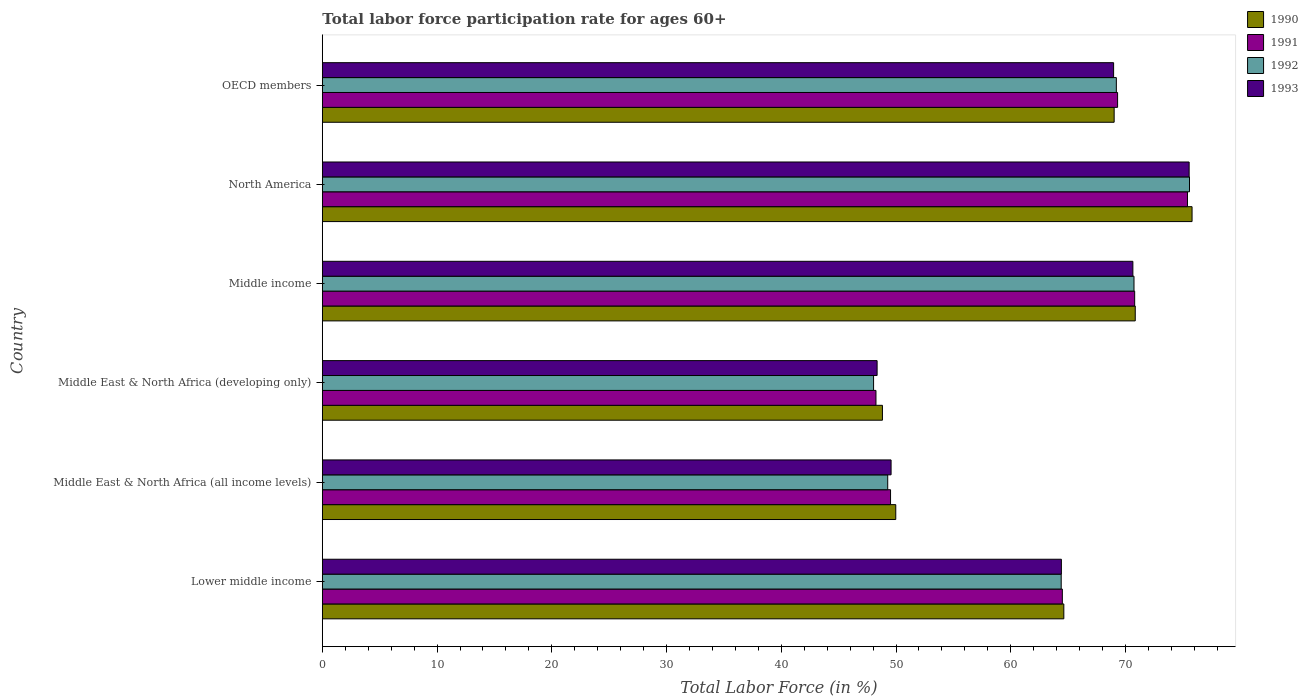How many groups of bars are there?
Ensure brevity in your answer.  6. Are the number of bars per tick equal to the number of legend labels?
Offer a very short reply. Yes. Are the number of bars on each tick of the Y-axis equal?
Your answer should be compact. Yes. How many bars are there on the 5th tick from the top?
Provide a short and direct response. 4. How many bars are there on the 4th tick from the bottom?
Ensure brevity in your answer.  4. What is the label of the 2nd group of bars from the top?
Provide a short and direct response. North America. In how many cases, is the number of bars for a given country not equal to the number of legend labels?
Ensure brevity in your answer.  0. What is the labor force participation rate in 1991 in Lower middle income?
Offer a very short reply. 64.5. Across all countries, what is the maximum labor force participation rate in 1990?
Offer a terse response. 75.8. Across all countries, what is the minimum labor force participation rate in 1992?
Make the answer very short. 48.04. In which country was the labor force participation rate in 1993 maximum?
Your response must be concise. North America. In which country was the labor force participation rate in 1990 minimum?
Keep it short and to the point. Middle East & North Africa (developing only). What is the total labor force participation rate in 1992 in the graph?
Keep it short and to the point. 377.24. What is the difference between the labor force participation rate in 1991 in Middle East & North Africa (developing only) and that in North America?
Make the answer very short. -27.15. What is the difference between the labor force participation rate in 1991 in OECD members and the labor force participation rate in 1990 in Middle East & North Africa (all income levels)?
Give a very brief answer. 19.33. What is the average labor force participation rate in 1993 per country?
Make the answer very short. 62.92. What is the difference between the labor force participation rate in 1991 and labor force participation rate in 1993 in OECD members?
Provide a short and direct response. 0.35. What is the ratio of the labor force participation rate in 1992 in Middle East & North Africa (developing only) to that in North America?
Make the answer very short. 0.64. Is the labor force participation rate in 1993 in Lower middle income less than that in North America?
Your answer should be very brief. Yes. Is the difference between the labor force participation rate in 1991 in Middle East & North Africa (developing only) and Middle income greater than the difference between the labor force participation rate in 1993 in Middle East & North Africa (developing only) and Middle income?
Make the answer very short. No. What is the difference between the highest and the second highest labor force participation rate in 1993?
Keep it short and to the point. 4.9. What is the difference between the highest and the lowest labor force participation rate in 1991?
Your response must be concise. 27.15. Is it the case that in every country, the sum of the labor force participation rate in 1992 and labor force participation rate in 1990 is greater than the sum of labor force participation rate in 1991 and labor force participation rate in 1993?
Your answer should be very brief. No. What does the 1st bar from the bottom in OECD members represents?
Make the answer very short. 1990. Is it the case that in every country, the sum of the labor force participation rate in 1991 and labor force participation rate in 1992 is greater than the labor force participation rate in 1993?
Provide a short and direct response. Yes. How many bars are there?
Your answer should be very brief. 24. Are all the bars in the graph horizontal?
Keep it short and to the point. Yes. How many countries are there in the graph?
Ensure brevity in your answer.  6. What is the difference between two consecutive major ticks on the X-axis?
Offer a terse response. 10. Are the values on the major ticks of X-axis written in scientific E-notation?
Give a very brief answer. No. Does the graph contain any zero values?
Your answer should be compact. No. Does the graph contain grids?
Your response must be concise. No. What is the title of the graph?
Offer a very short reply. Total labor force participation rate for ages 60+. What is the label or title of the Y-axis?
Provide a succinct answer. Country. What is the Total Labor Force (in %) in 1990 in Lower middle income?
Your answer should be compact. 64.63. What is the Total Labor Force (in %) of 1991 in Lower middle income?
Make the answer very short. 64.5. What is the Total Labor Force (in %) of 1992 in Lower middle income?
Keep it short and to the point. 64.4. What is the Total Labor Force (in %) of 1993 in Lower middle income?
Ensure brevity in your answer.  64.41. What is the Total Labor Force (in %) of 1990 in Middle East & North Africa (all income levels)?
Offer a very short reply. 49.98. What is the Total Labor Force (in %) in 1991 in Middle East & North Africa (all income levels)?
Make the answer very short. 49.52. What is the Total Labor Force (in %) of 1992 in Middle East & North Africa (all income levels)?
Give a very brief answer. 49.28. What is the Total Labor Force (in %) of 1993 in Middle East & North Africa (all income levels)?
Keep it short and to the point. 49.57. What is the Total Labor Force (in %) of 1990 in Middle East & North Africa (developing only)?
Ensure brevity in your answer.  48.82. What is the Total Labor Force (in %) of 1991 in Middle East & North Africa (developing only)?
Your answer should be compact. 48.25. What is the Total Labor Force (in %) of 1992 in Middle East & North Africa (developing only)?
Provide a succinct answer. 48.04. What is the Total Labor Force (in %) in 1993 in Middle East & North Africa (developing only)?
Give a very brief answer. 48.35. What is the Total Labor Force (in %) of 1990 in Middle income?
Ensure brevity in your answer.  70.85. What is the Total Labor Force (in %) in 1991 in Middle income?
Offer a very short reply. 70.8. What is the Total Labor Force (in %) in 1992 in Middle income?
Your answer should be very brief. 70.74. What is the Total Labor Force (in %) of 1993 in Middle income?
Offer a terse response. 70.64. What is the Total Labor Force (in %) of 1990 in North America?
Keep it short and to the point. 75.8. What is the Total Labor Force (in %) of 1991 in North America?
Your response must be concise. 75.4. What is the Total Labor Force (in %) in 1992 in North America?
Your answer should be very brief. 75.58. What is the Total Labor Force (in %) of 1993 in North America?
Your answer should be compact. 75.55. What is the Total Labor Force (in %) in 1990 in OECD members?
Give a very brief answer. 69.01. What is the Total Labor Force (in %) of 1991 in OECD members?
Your answer should be compact. 69.31. What is the Total Labor Force (in %) in 1992 in OECD members?
Give a very brief answer. 69.2. What is the Total Labor Force (in %) of 1993 in OECD members?
Ensure brevity in your answer.  68.97. Across all countries, what is the maximum Total Labor Force (in %) of 1990?
Provide a succinct answer. 75.8. Across all countries, what is the maximum Total Labor Force (in %) of 1991?
Make the answer very short. 75.4. Across all countries, what is the maximum Total Labor Force (in %) of 1992?
Your answer should be very brief. 75.58. Across all countries, what is the maximum Total Labor Force (in %) in 1993?
Provide a succinct answer. 75.55. Across all countries, what is the minimum Total Labor Force (in %) in 1990?
Your answer should be very brief. 48.82. Across all countries, what is the minimum Total Labor Force (in %) in 1991?
Make the answer very short. 48.25. Across all countries, what is the minimum Total Labor Force (in %) in 1992?
Provide a short and direct response. 48.04. Across all countries, what is the minimum Total Labor Force (in %) in 1993?
Your answer should be very brief. 48.35. What is the total Total Labor Force (in %) in 1990 in the graph?
Offer a terse response. 379.09. What is the total Total Labor Force (in %) of 1991 in the graph?
Your answer should be very brief. 377.79. What is the total Total Labor Force (in %) in 1992 in the graph?
Give a very brief answer. 377.24. What is the total Total Labor Force (in %) of 1993 in the graph?
Give a very brief answer. 377.49. What is the difference between the Total Labor Force (in %) in 1990 in Lower middle income and that in Middle East & North Africa (all income levels)?
Ensure brevity in your answer.  14.65. What is the difference between the Total Labor Force (in %) in 1991 in Lower middle income and that in Middle East & North Africa (all income levels)?
Make the answer very short. 14.97. What is the difference between the Total Labor Force (in %) of 1992 in Lower middle income and that in Middle East & North Africa (all income levels)?
Give a very brief answer. 15.12. What is the difference between the Total Labor Force (in %) of 1993 in Lower middle income and that in Middle East & North Africa (all income levels)?
Provide a short and direct response. 14.84. What is the difference between the Total Labor Force (in %) in 1990 in Lower middle income and that in Middle East & North Africa (developing only)?
Make the answer very short. 15.81. What is the difference between the Total Labor Force (in %) in 1991 in Lower middle income and that in Middle East & North Africa (developing only)?
Offer a terse response. 16.24. What is the difference between the Total Labor Force (in %) in 1992 in Lower middle income and that in Middle East & North Africa (developing only)?
Offer a very short reply. 16.35. What is the difference between the Total Labor Force (in %) in 1993 in Lower middle income and that in Middle East & North Africa (developing only)?
Offer a terse response. 16.06. What is the difference between the Total Labor Force (in %) of 1990 in Lower middle income and that in Middle income?
Your answer should be compact. -6.22. What is the difference between the Total Labor Force (in %) of 1991 in Lower middle income and that in Middle income?
Keep it short and to the point. -6.3. What is the difference between the Total Labor Force (in %) of 1992 in Lower middle income and that in Middle income?
Make the answer very short. -6.34. What is the difference between the Total Labor Force (in %) in 1993 in Lower middle income and that in Middle income?
Offer a terse response. -6.23. What is the difference between the Total Labor Force (in %) of 1990 in Lower middle income and that in North America?
Your answer should be compact. -11.18. What is the difference between the Total Labor Force (in %) of 1991 in Lower middle income and that in North America?
Provide a succinct answer. -10.91. What is the difference between the Total Labor Force (in %) of 1992 in Lower middle income and that in North America?
Your answer should be very brief. -11.18. What is the difference between the Total Labor Force (in %) of 1993 in Lower middle income and that in North America?
Provide a succinct answer. -11.14. What is the difference between the Total Labor Force (in %) of 1990 in Lower middle income and that in OECD members?
Your answer should be very brief. -4.39. What is the difference between the Total Labor Force (in %) in 1991 in Lower middle income and that in OECD members?
Your answer should be very brief. -4.81. What is the difference between the Total Labor Force (in %) in 1992 in Lower middle income and that in OECD members?
Your response must be concise. -4.81. What is the difference between the Total Labor Force (in %) in 1993 in Lower middle income and that in OECD members?
Ensure brevity in your answer.  -4.55. What is the difference between the Total Labor Force (in %) in 1990 in Middle East & North Africa (all income levels) and that in Middle East & North Africa (developing only)?
Provide a short and direct response. 1.16. What is the difference between the Total Labor Force (in %) of 1991 in Middle East & North Africa (all income levels) and that in Middle East & North Africa (developing only)?
Give a very brief answer. 1.27. What is the difference between the Total Labor Force (in %) of 1992 in Middle East & North Africa (all income levels) and that in Middle East & North Africa (developing only)?
Your answer should be very brief. 1.23. What is the difference between the Total Labor Force (in %) of 1993 in Middle East & North Africa (all income levels) and that in Middle East & North Africa (developing only)?
Provide a short and direct response. 1.22. What is the difference between the Total Labor Force (in %) of 1990 in Middle East & North Africa (all income levels) and that in Middle income?
Ensure brevity in your answer.  -20.87. What is the difference between the Total Labor Force (in %) in 1991 in Middle East & North Africa (all income levels) and that in Middle income?
Offer a terse response. -21.28. What is the difference between the Total Labor Force (in %) of 1992 in Middle East & North Africa (all income levels) and that in Middle income?
Your response must be concise. -21.46. What is the difference between the Total Labor Force (in %) in 1993 in Middle East & North Africa (all income levels) and that in Middle income?
Give a very brief answer. -21.07. What is the difference between the Total Labor Force (in %) of 1990 in Middle East & North Africa (all income levels) and that in North America?
Keep it short and to the point. -25.82. What is the difference between the Total Labor Force (in %) in 1991 in Middle East & North Africa (all income levels) and that in North America?
Keep it short and to the point. -25.88. What is the difference between the Total Labor Force (in %) of 1992 in Middle East & North Africa (all income levels) and that in North America?
Ensure brevity in your answer.  -26.3. What is the difference between the Total Labor Force (in %) of 1993 in Middle East & North Africa (all income levels) and that in North America?
Provide a succinct answer. -25.98. What is the difference between the Total Labor Force (in %) in 1990 in Middle East & North Africa (all income levels) and that in OECD members?
Provide a succinct answer. -19.03. What is the difference between the Total Labor Force (in %) of 1991 in Middle East & North Africa (all income levels) and that in OECD members?
Your answer should be compact. -19.79. What is the difference between the Total Labor Force (in %) of 1992 in Middle East & North Africa (all income levels) and that in OECD members?
Give a very brief answer. -19.93. What is the difference between the Total Labor Force (in %) of 1993 in Middle East & North Africa (all income levels) and that in OECD members?
Provide a short and direct response. -19.39. What is the difference between the Total Labor Force (in %) in 1990 in Middle East & North Africa (developing only) and that in Middle income?
Your answer should be compact. -22.03. What is the difference between the Total Labor Force (in %) of 1991 in Middle East & North Africa (developing only) and that in Middle income?
Ensure brevity in your answer.  -22.55. What is the difference between the Total Labor Force (in %) of 1992 in Middle East & North Africa (developing only) and that in Middle income?
Provide a short and direct response. -22.7. What is the difference between the Total Labor Force (in %) of 1993 in Middle East & North Africa (developing only) and that in Middle income?
Provide a succinct answer. -22.29. What is the difference between the Total Labor Force (in %) of 1990 in Middle East & North Africa (developing only) and that in North America?
Offer a terse response. -26.99. What is the difference between the Total Labor Force (in %) of 1991 in Middle East & North Africa (developing only) and that in North America?
Your answer should be compact. -27.15. What is the difference between the Total Labor Force (in %) of 1992 in Middle East & North Africa (developing only) and that in North America?
Offer a terse response. -27.53. What is the difference between the Total Labor Force (in %) of 1993 in Middle East & North Africa (developing only) and that in North America?
Your answer should be very brief. -27.2. What is the difference between the Total Labor Force (in %) in 1990 in Middle East & North Africa (developing only) and that in OECD members?
Provide a succinct answer. -20.2. What is the difference between the Total Labor Force (in %) of 1991 in Middle East & North Africa (developing only) and that in OECD members?
Keep it short and to the point. -21.06. What is the difference between the Total Labor Force (in %) of 1992 in Middle East & North Africa (developing only) and that in OECD members?
Your answer should be compact. -21.16. What is the difference between the Total Labor Force (in %) of 1993 in Middle East & North Africa (developing only) and that in OECD members?
Ensure brevity in your answer.  -20.61. What is the difference between the Total Labor Force (in %) of 1990 in Middle income and that in North America?
Keep it short and to the point. -4.95. What is the difference between the Total Labor Force (in %) of 1991 in Middle income and that in North America?
Offer a terse response. -4.6. What is the difference between the Total Labor Force (in %) in 1992 in Middle income and that in North America?
Offer a very short reply. -4.84. What is the difference between the Total Labor Force (in %) of 1993 in Middle income and that in North America?
Make the answer very short. -4.9. What is the difference between the Total Labor Force (in %) of 1990 in Middle income and that in OECD members?
Make the answer very short. 1.84. What is the difference between the Total Labor Force (in %) in 1991 in Middle income and that in OECD members?
Ensure brevity in your answer.  1.49. What is the difference between the Total Labor Force (in %) in 1992 in Middle income and that in OECD members?
Make the answer very short. 1.54. What is the difference between the Total Labor Force (in %) in 1993 in Middle income and that in OECD members?
Provide a short and direct response. 1.68. What is the difference between the Total Labor Force (in %) of 1990 in North America and that in OECD members?
Make the answer very short. 6.79. What is the difference between the Total Labor Force (in %) in 1991 in North America and that in OECD members?
Make the answer very short. 6.09. What is the difference between the Total Labor Force (in %) of 1992 in North America and that in OECD members?
Ensure brevity in your answer.  6.38. What is the difference between the Total Labor Force (in %) of 1993 in North America and that in OECD members?
Your answer should be very brief. 6.58. What is the difference between the Total Labor Force (in %) in 1990 in Lower middle income and the Total Labor Force (in %) in 1991 in Middle East & North Africa (all income levels)?
Provide a short and direct response. 15.1. What is the difference between the Total Labor Force (in %) of 1990 in Lower middle income and the Total Labor Force (in %) of 1992 in Middle East & North Africa (all income levels)?
Provide a short and direct response. 15.35. What is the difference between the Total Labor Force (in %) of 1990 in Lower middle income and the Total Labor Force (in %) of 1993 in Middle East & North Africa (all income levels)?
Offer a very short reply. 15.06. What is the difference between the Total Labor Force (in %) of 1991 in Lower middle income and the Total Labor Force (in %) of 1992 in Middle East & North Africa (all income levels)?
Provide a succinct answer. 15.22. What is the difference between the Total Labor Force (in %) of 1991 in Lower middle income and the Total Labor Force (in %) of 1993 in Middle East & North Africa (all income levels)?
Your answer should be very brief. 14.93. What is the difference between the Total Labor Force (in %) of 1992 in Lower middle income and the Total Labor Force (in %) of 1993 in Middle East & North Africa (all income levels)?
Offer a very short reply. 14.83. What is the difference between the Total Labor Force (in %) of 1990 in Lower middle income and the Total Labor Force (in %) of 1991 in Middle East & North Africa (developing only)?
Provide a succinct answer. 16.37. What is the difference between the Total Labor Force (in %) of 1990 in Lower middle income and the Total Labor Force (in %) of 1992 in Middle East & North Africa (developing only)?
Offer a terse response. 16.58. What is the difference between the Total Labor Force (in %) in 1990 in Lower middle income and the Total Labor Force (in %) in 1993 in Middle East & North Africa (developing only)?
Give a very brief answer. 16.27. What is the difference between the Total Labor Force (in %) in 1991 in Lower middle income and the Total Labor Force (in %) in 1992 in Middle East & North Africa (developing only)?
Your response must be concise. 16.45. What is the difference between the Total Labor Force (in %) in 1991 in Lower middle income and the Total Labor Force (in %) in 1993 in Middle East & North Africa (developing only)?
Your answer should be very brief. 16.15. What is the difference between the Total Labor Force (in %) of 1992 in Lower middle income and the Total Labor Force (in %) of 1993 in Middle East & North Africa (developing only)?
Offer a terse response. 16.05. What is the difference between the Total Labor Force (in %) in 1990 in Lower middle income and the Total Labor Force (in %) in 1991 in Middle income?
Offer a very short reply. -6.17. What is the difference between the Total Labor Force (in %) in 1990 in Lower middle income and the Total Labor Force (in %) in 1992 in Middle income?
Offer a terse response. -6.12. What is the difference between the Total Labor Force (in %) of 1990 in Lower middle income and the Total Labor Force (in %) of 1993 in Middle income?
Your answer should be compact. -6.02. What is the difference between the Total Labor Force (in %) of 1991 in Lower middle income and the Total Labor Force (in %) of 1992 in Middle income?
Your answer should be compact. -6.24. What is the difference between the Total Labor Force (in %) in 1991 in Lower middle income and the Total Labor Force (in %) in 1993 in Middle income?
Make the answer very short. -6.15. What is the difference between the Total Labor Force (in %) in 1992 in Lower middle income and the Total Labor Force (in %) in 1993 in Middle income?
Provide a short and direct response. -6.25. What is the difference between the Total Labor Force (in %) of 1990 in Lower middle income and the Total Labor Force (in %) of 1991 in North America?
Your answer should be very brief. -10.78. What is the difference between the Total Labor Force (in %) in 1990 in Lower middle income and the Total Labor Force (in %) in 1992 in North America?
Ensure brevity in your answer.  -10.95. What is the difference between the Total Labor Force (in %) of 1990 in Lower middle income and the Total Labor Force (in %) of 1993 in North America?
Your answer should be compact. -10.92. What is the difference between the Total Labor Force (in %) in 1991 in Lower middle income and the Total Labor Force (in %) in 1992 in North America?
Your answer should be very brief. -11.08. What is the difference between the Total Labor Force (in %) of 1991 in Lower middle income and the Total Labor Force (in %) of 1993 in North America?
Ensure brevity in your answer.  -11.05. What is the difference between the Total Labor Force (in %) in 1992 in Lower middle income and the Total Labor Force (in %) in 1993 in North America?
Ensure brevity in your answer.  -11.15. What is the difference between the Total Labor Force (in %) in 1990 in Lower middle income and the Total Labor Force (in %) in 1991 in OECD members?
Make the answer very short. -4.69. What is the difference between the Total Labor Force (in %) of 1990 in Lower middle income and the Total Labor Force (in %) of 1992 in OECD members?
Make the answer very short. -4.58. What is the difference between the Total Labor Force (in %) of 1990 in Lower middle income and the Total Labor Force (in %) of 1993 in OECD members?
Provide a succinct answer. -4.34. What is the difference between the Total Labor Force (in %) in 1991 in Lower middle income and the Total Labor Force (in %) in 1992 in OECD members?
Your answer should be very brief. -4.71. What is the difference between the Total Labor Force (in %) of 1991 in Lower middle income and the Total Labor Force (in %) of 1993 in OECD members?
Offer a terse response. -4.47. What is the difference between the Total Labor Force (in %) in 1992 in Lower middle income and the Total Labor Force (in %) in 1993 in OECD members?
Your answer should be compact. -4.57. What is the difference between the Total Labor Force (in %) of 1990 in Middle East & North Africa (all income levels) and the Total Labor Force (in %) of 1991 in Middle East & North Africa (developing only)?
Provide a succinct answer. 1.73. What is the difference between the Total Labor Force (in %) in 1990 in Middle East & North Africa (all income levels) and the Total Labor Force (in %) in 1992 in Middle East & North Africa (developing only)?
Give a very brief answer. 1.93. What is the difference between the Total Labor Force (in %) in 1990 in Middle East & North Africa (all income levels) and the Total Labor Force (in %) in 1993 in Middle East & North Africa (developing only)?
Keep it short and to the point. 1.63. What is the difference between the Total Labor Force (in %) of 1991 in Middle East & North Africa (all income levels) and the Total Labor Force (in %) of 1992 in Middle East & North Africa (developing only)?
Offer a terse response. 1.48. What is the difference between the Total Labor Force (in %) of 1991 in Middle East & North Africa (all income levels) and the Total Labor Force (in %) of 1993 in Middle East & North Africa (developing only)?
Your answer should be very brief. 1.17. What is the difference between the Total Labor Force (in %) in 1992 in Middle East & North Africa (all income levels) and the Total Labor Force (in %) in 1993 in Middle East & North Africa (developing only)?
Provide a short and direct response. 0.93. What is the difference between the Total Labor Force (in %) of 1990 in Middle East & North Africa (all income levels) and the Total Labor Force (in %) of 1991 in Middle income?
Your answer should be compact. -20.82. What is the difference between the Total Labor Force (in %) in 1990 in Middle East & North Africa (all income levels) and the Total Labor Force (in %) in 1992 in Middle income?
Offer a very short reply. -20.76. What is the difference between the Total Labor Force (in %) in 1990 in Middle East & North Africa (all income levels) and the Total Labor Force (in %) in 1993 in Middle income?
Offer a terse response. -20.66. What is the difference between the Total Labor Force (in %) of 1991 in Middle East & North Africa (all income levels) and the Total Labor Force (in %) of 1992 in Middle income?
Your answer should be compact. -21.22. What is the difference between the Total Labor Force (in %) of 1991 in Middle East & North Africa (all income levels) and the Total Labor Force (in %) of 1993 in Middle income?
Make the answer very short. -21.12. What is the difference between the Total Labor Force (in %) of 1992 in Middle East & North Africa (all income levels) and the Total Labor Force (in %) of 1993 in Middle income?
Your answer should be compact. -21.37. What is the difference between the Total Labor Force (in %) in 1990 in Middle East & North Africa (all income levels) and the Total Labor Force (in %) in 1991 in North America?
Ensure brevity in your answer.  -25.42. What is the difference between the Total Labor Force (in %) in 1990 in Middle East & North Africa (all income levels) and the Total Labor Force (in %) in 1992 in North America?
Keep it short and to the point. -25.6. What is the difference between the Total Labor Force (in %) of 1990 in Middle East & North Africa (all income levels) and the Total Labor Force (in %) of 1993 in North America?
Provide a succinct answer. -25.57. What is the difference between the Total Labor Force (in %) of 1991 in Middle East & North Africa (all income levels) and the Total Labor Force (in %) of 1992 in North America?
Offer a very short reply. -26.06. What is the difference between the Total Labor Force (in %) in 1991 in Middle East & North Africa (all income levels) and the Total Labor Force (in %) in 1993 in North America?
Your answer should be compact. -26.03. What is the difference between the Total Labor Force (in %) of 1992 in Middle East & North Africa (all income levels) and the Total Labor Force (in %) of 1993 in North America?
Keep it short and to the point. -26.27. What is the difference between the Total Labor Force (in %) of 1990 in Middle East & North Africa (all income levels) and the Total Labor Force (in %) of 1991 in OECD members?
Provide a succinct answer. -19.33. What is the difference between the Total Labor Force (in %) of 1990 in Middle East & North Africa (all income levels) and the Total Labor Force (in %) of 1992 in OECD members?
Provide a short and direct response. -19.22. What is the difference between the Total Labor Force (in %) in 1990 in Middle East & North Africa (all income levels) and the Total Labor Force (in %) in 1993 in OECD members?
Give a very brief answer. -18.99. What is the difference between the Total Labor Force (in %) of 1991 in Middle East & North Africa (all income levels) and the Total Labor Force (in %) of 1992 in OECD members?
Your answer should be compact. -19.68. What is the difference between the Total Labor Force (in %) in 1991 in Middle East & North Africa (all income levels) and the Total Labor Force (in %) in 1993 in OECD members?
Provide a succinct answer. -19.44. What is the difference between the Total Labor Force (in %) of 1992 in Middle East & North Africa (all income levels) and the Total Labor Force (in %) of 1993 in OECD members?
Offer a terse response. -19.69. What is the difference between the Total Labor Force (in %) in 1990 in Middle East & North Africa (developing only) and the Total Labor Force (in %) in 1991 in Middle income?
Offer a very short reply. -21.98. What is the difference between the Total Labor Force (in %) in 1990 in Middle East & North Africa (developing only) and the Total Labor Force (in %) in 1992 in Middle income?
Offer a terse response. -21.93. What is the difference between the Total Labor Force (in %) of 1990 in Middle East & North Africa (developing only) and the Total Labor Force (in %) of 1993 in Middle income?
Give a very brief answer. -21.83. What is the difference between the Total Labor Force (in %) in 1991 in Middle East & North Africa (developing only) and the Total Labor Force (in %) in 1992 in Middle income?
Provide a short and direct response. -22.49. What is the difference between the Total Labor Force (in %) in 1991 in Middle East & North Africa (developing only) and the Total Labor Force (in %) in 1993 in Middle income?
Keep it short and to the point. -22.39. What is the difference between the Total Labor Force (in %) in 1992 in Middle East & North Africa (developing only) and the Total Labor Force (in %) in 1993 in Middle income?
Your response must be concise. -22.6. What is the difference between the Total Labor Force (in %) of 1990 in Middle East & North Africa (developing only) and the Total Labor Force (in %) of 1991 in North America?
Your answer should be very brief. -26.59. What is the difference between the Total Labor Force (in %) in 1990 in Middle East & North Africa (developing only) and the Total Labor Force (in %) in 1992 in North America?
Give a very brief answer. -26.76. What is the difference between the Total Labor Force (in %) of 1990 in Middle East & North Africa (developing only) and the Total Labor Force (in %) of 1993 in North America?
Your response must be concise. -26.73. What is the difference between the Total Labor Force (in %) of 1991 in Middle East & North Africa (developing only) and the Total Labor Force (in %) of 1992 in North America?
Offer a terse response. -27.33. What is the difference between the Total Labor Force (in %) of 1991 in Middle East & North Africa (developing only) and the Total Labor Force (in %) of 1993 in North America?
Your answer should be very brief. -27.3. What is the difference between the Total Labor Force (in %) of 1992 in Middle East & North Africa (developing only) and the Total Labor Force (in %) of 1993 in North America?
Provide a short and direct response. -27.5. What is the difference between the Total Labor Force (in %) in 1990 in Middle East & North Africa (developing only) and the Total Labor Force (in %) in 1991 in OECD members?
Offer a very short reply. -20.5. What is the difference between the Total Labor Force (in %) in 1990 in Middle East & North Africa (developing only) and the Total Labor Force (in %) in 1992 in OECD members?
Make the answer very short. -20.39. What is the difference between the Total Labor Force (in %) in 1990 in Middle East & North Africa (developing only) and the Total Labor Force (in %) in 1993 in OECD members?
Make the answer very short. -20.15. What is the difference between the Total Labor Force (in %) of 1991 in Middle East & North Africa (developing only) and the Total Labor Force (in %) of 1992 in OECD members?
Your answer should be very brief. -20.95. What is the difference between the Total Labor Force (in %) of 1991 in Middle East & North Africa (developing only) and the Total Labor Force (in %) of 1993 in OECD members?
Keep it short and to the point. -20.71. What is the difference between the Total Labor Force (in %) in 1992 in Middle East & North Africa (developing only) and the Total Labor Force (in %) in 1993 in OECD members?
Your response must be concise. -20.92. What is the difference between the Total Labor Force (in %) of 1990 in Middle income and the Total Labor Force (in %) of 1991 in North America?
Offer a very short reply. -4.55. What is the difference between the Total Labor Force (in %) in 1990 in Middle income and the Total Labor Force (in %) in 1992 in North America?
Keep it short and to the point. -4.73. What is the difference between the Total Labor Force (in %) of 1990 in Middle income and the Total Labor Force (in %) of 1993 in North America?
Your response must be concise. -4.7. What is the difference between the Total Labor Force (in %) of 1991 in Middle income and the Total Labor Force (in %) of 1992 in North America?
Offer a terse response. -4.78. What is the difference between the Total Labor Force (in %) of 1991 in Middle income and the Total Labor Force (in %) of 1993 in North America?
Your response must be concise. -4.75. What is the difference between the Total Labor Force (in %) in 1992 in Middle income and the Total Labor Force (in %) in 1993 in North America?
Keep it short and to the point. -4.81. What is the difference between the Total Labor Force (in %) in 1990 in Middle income and the Total Labor Force (in %) in 1991 in OECD members?
Provide a short and direct response. 1.54. What is the difference between the Total Labor Force (in %) of 1990 in Middle income and the Total Labor Force (in %) of 1992 in OECD members?
Provide a short and direct response. 1.65. What is the difference between the Total Labor Force (in %) of 1990 in Middle income and the Total Labor Force (in %) of 1993 in OECD members?
Give a very brief answer. 1.89. What is the difference between the Total Labor Force (in %) of 1991 in Middle income and the Total Labor Force (in %) of 1992 in OECD members?
Offer a very short reply. 1.6. What is the difference between the Total Labor Force (in %) in 1991 in Middle income and the Total Labor Force (in %) in 1993 in OECD members?
Give a very brief answer. 1.84. What is the difference between the Total Labor Force (in %) in 1992 in Middle income and the Total Labor Force (in %) in 1993 in OECD members?
Make the answer very short. 1.78. What is the difference between the Total Labor Force (in %) in 1990 in North America and the Total Labor Force (in %) in 1991 in OECD members?
Keep it short and to the point. 6.49. What is the difference between the Total Labor Force (in %) of 1990 in North America and the Total Labor Force (in %) of 1992 in OECD members?
Make the answer very short. 6.6. What is the difference between the Total Labor Force (in %) of 1990 in North America and the Total Labor Force (in %) of 1993 in OECD members?
Keep it short and to the point. 6.84. What is the difference between the Total Labor Force (in %) in 1991 in North America and the Total Labor Force (in %) in 1992 in OECD members?
Offer a terse response. 6.2. What is the difference between the Total Labor Force (in %) in 1991 in North America and the Total Labor Force (in %) in 1993 in OECD members?
Provide a succinct answer. 6.44. What is the difference between the Total Labor Force (in %) in 1992 in North America and the Total Labor Force (in %) in 1993 in OECD members?
Your answer should be compact. 6.61. What is the average Total Labor Force (in %) of 1990 per country?
Ensure brevity in your answer.  63.18. What is the average Total Labor Force (in %) of 1991 per country?
Keep it short and to the point. 62.96. What is the average Total Labor Force (in %) of 1992 per country?
Your answer should be compact. 62.87. What is the average Total Labor Force (in %) of 1993 per country?
Provide a short and direct response. 62.92. What is the difference between the Total Labor Force (in %) of 1990 and Total Labor Force (in %) of 1991 in Lower middle income?
Your answer should be very brief. 0.13. What is the difference between the Total Labor Force (in %) of 1990 and Total Labor Force (in %) of 1992 in Lower middle income?
Offer a very short reply. 0.23. What is the difference between the Total Labor Force (in %) of 1990 and Total Labor Force (in %) of 1993 in Lower middle income?
Offer a very short reply. 0.21. What is the difference between the Total Labor Force (in %) of 1991 and Total Labor Force (in %) of 1992 in Lower middle income?
Offer a terse response. 0.1. What is the difference between the Total Labor Force (in %) in 1991 and Total Labor Force (in %) in 1993 in Lower middle income?
Your answer should be compact. 0.08. What is the difference between the Total Labor Force (in %) in 1992 and Total Labor Force (in %) in 1993 in Lower middle income?
Give a very brief answer. -0.02. What is the difference between the Total Labor Force (in %) in 1990 and Total Labor Force (in %) in 1991 in Middle East & North Africa (all income levels)?
Ensure brevity in your answer.  0.46. What is the difference between the Total Labor Force (in %) of 1990 and Total Labor Force (in %) of 1992 in Middle East & North Africa (all income levels)?
Give a very brief answer. 0.7. What is the difference between the Total Labor Force (in %) of 1990 and Total Labor Force (in %) of 1993 in Middle East & North Africa (all income levels)?
Your answer should be very brief. 0.41. What is the difference between the Total Labor Force (in %) of 1991 and Total Labor Force (in %) of 1992 in Middle East & North Africa (all income levels)?
Your response must be concise. 0.25. What is the difference between the Total Labor Force (in %) in 1991 and Total Labor Force (in %) in 1993 in Middle East & North Africa (all income levels)?
Make the answer very short. -0.05. What is the difference between the Total Labor Force (in %) of 1992 and Total Labor Force (in %) of 1993 in Middle East & North Africa (all income levels)?
Your answer should be compact. -0.29. What is the difference between the Total Labor Force (in %) in 1990 and Total Labor Force (in %) in 1991 in Middle East & North Africa (developing only)?
Provide a short and direct response. 0.56. What is the difference between the Total Labor Force (in %) in 1990 and Total Labor Force (in %) in 1992 in Middle East & North Africa (developing only)?
Make the answer very short. 0.77. What is the difference between the Total Labor Force (in %) of 1990 and Total Labor Force (in %) of 1993 in Middle East & North Africa (developing only)?
Provide a short and direct response. 0.46. What is the difference between the Total Labor Force (in %) in 1991 and Total Labor Force (in %) in 1992 in Middle East & North Africa (developing only)?
Offer a very short reply. 0.21. What is the difference between the Total Labor Force (in %) in 1991 and Total Labor Force (in %) in 1993 in Middle East & North Africa (developing only)?
Provide a succinct answer. -0.1. What is the difference between the Total Labor Force (in %) of 1992 and Total Labor Force (in %) of 1993 in Middle East & North Africa (developing only)?
Keep it short and to the point. -0.31. What is the difference between the Total Labor Force (in %) in 1990 and Total Labor Force (in %) in 1991 in Middle income?
Keep it short and to the point. 0.05. What is the difference between the Total Labor Force (in %) in 1990 and Total Labor Force (in %) in 1992 in Middle income?
Your answer should be compact. 0.11. What is the difference between the Total Labor Force (in %) in 1990 and Total Labor Force (in %) in 1993 in Middle income?
Offer a terse response. 0.21. What is the difference between the Total Labor Force (in %) of 1991 and Total Labor Force (in %) of 1992 in Middle income?
Make the answer very short. 0.06. What is the difference between the Total Labor Force (in %) in 1991 and Total Labor Force (in %) in 1993 in Middle income?
Offer a terse response. 0.16. What is the difference between the Total Labor Force (in %) of 1992 and Total Labor Force (in %) of 1993 in Middle income?
Offer a very short reply. 0.1. What is the difference between the Total Labor Force (in %) in 1990 and Total Labor Force (in %) in 1991 in North America?
Your answer should be very brief. 0.4. What is the difference between the Total Labor Force (in %) of 1990 and Total Labor Force (in %) of 1992 in North America?
Offer a terse response. 0.22. What is the difference between the Total Labor Force (in %) in 1990 and Total Labor Force (in %) in 1993 in North America?
Offer a very short reply. 0.25. What is the difference between the Total Labor Force (in %) in 1991 and Total Labor Force (in %) in 1992 in North America?
Give a very brief answer. -0.18. What is the difference between the Total Labor Force (in %) of 1991 and Total Labor Force (in %) of 1993 in North America?
Offer a very short reply. -0.15. What is the difference between the Total Labor Force (in %) of 1992 and Total Labor Force (in %) of 1993 in North America?
Provide a succinct answer. 0.03. What is the difference between the Total Labor Force (in %) of 1990 and Total Labor Force (in %) of 1991 in OECD members?
Make the answer very short. -0.3. What is the difference between the Total Labor Force (in %) of 1990 and Total Labor Force (in %) of 1992 in OECD members?
Give a very brief answer. -0.19. What is the difference between the Total Labor Force (in %) in 1990 and Total Labor Force (in %) in 1993 in OECD members?
Ensure brevity in your answer.  0.05. What is the difference between the Total Labor Force (in %) of 1991 and Total Labor Force (in %) of 1992 in OECD members?
Your answer should be very brief. 0.11. What is the difference between the Total Labor Force (in %) of 1991 and Total Labor Force (in %) of 1993 in OECD members?
Provide a succinct answer. 0.35. What is the difference between the Total Labor Force (in %) of 1992 and Total Labor Force (in %) of 1993 in OECD members?
Provide a succinct answer. 0.24. What is the ratio of the Total Labor Force (in %) in 1990 in Lower middle income to that in Middle East & North Africa (all income levels)?
Give a very brief answer. 1.29. What is the ratio of the Total Labor Force (in %) in 1991 in Lower middle income to that in Middle East & North Africa (all income levels)?
Offer a terse response. 1.3. What is the ratio of the Total Labor Force (in %) of 1992 in Lower middle income to that in Middle East & North Africa (all income levels)?
Provide a succinct answer. 1.31. What is the ratio of the Total Labor Force (in %) in 1993 in Lower middle income to that in Middle East & North Africa (all income levels)?
Keep it short and to the point. 1.3. What is the ratio of the Total Labor Force (in %) in 1990 in Lower middle income to that in Middle East & North Africa (developing only)?
Provide a succinct answer. 1.32. What is the ratio of the Total Labor Force (in %) of 1991 in Lower middle income to that in Middle East & North Africa (developing only)?
Make the answer very short. 1.34. What is the ratio of the Total Labor Force (in %) in 1992 in Lower middle income to that in Middle East & North Africa (developing only)?
Ensure brevity in your answer.  1.34. What is the ratio of the Total Labor Force (in %) of 1993 in Lower middle income to that in Middle East & North Africa (developing only)?
Offer a terse response. 1.33. What is the ratio of the Total Labor Force (in %) of 1990 in Lower middle income to that in Middle income?
Make the answer very short. 0.91. What is the ratio of the Total Labor Force (in %) in 1991 in Lower middle income to that in Middle income?
Give a very brief answer. 0.91. What is the ratio of the Total Labor Force (in %) in 1992 in Lower middle income to that in Middle income?
Ensure brevity in your answer.  0.91. What is the ratio of the Total Labor Force (in %) in 1993 in Lower middle income to that in Middle income?
Provide a short and direct response. 0.91. What is the ratio of the Total Labor Force (in %) of 1990 in Lower middle income to that in North America?
Make the answer very short. 0.85. What is the ratio of the Total Labor Force (in %) in 1991 in Lower middle income to that in North America?
Ensure brevity in your answer.  0.86. What is the ratio of the Total Labor Force (in %) of 1992 in Lower middle income to that in North America?
Your answer should be very brief. 0.85. What is the ratio of the Total Labor Force (in %) in 1993 in Lower middle income to that in North America?
Provide a short and direct response. 0.85. What is the ratio of the Total Labor Force (in %) in 1990 in Lower middle income to that in OECD members?
Make the answer very short. 0.94. What is the ratio of the Total Labor Force (in %) in 1991 in Lower middle income to that in OECD members?
Keep it short and to the point. 0.93. What is the ratio of the Total Labor Force (in %) in 1992 in Lower middle income to that in OECD members?
Keep it short and to the point. 0.93. What is the ratio of the Total Labor Force (in %) in 1993 in Lower middle income to that in OECD members?
Give a very brief answer. 0.93. What is the ratio of the Total Labor Force (in %) in 1990 in Middle East & North Africa (all income levels) to that in Middle East & North Africa (developing only)?
Give a very brief answer. 1.02. What is the ratio of the Total Labor Force (in %) of 1991 in Middle East & North Africa (all income levels) to that in Middle East & North Africa (developing only)?
Ensure brevity in your answer.  1.03. What is the ratio of the Total Labor Force (in %) of 1992 in Middle East & North Africa (all income levels) to that in Middle East & North Africa (developing only)?
Make the answer very short. 1.03. What is the ratio of the Total Labor Force (in %) of 1993 in Middle East & North Africa (all income levels) to that in Middle East & North Africa (developing only)?
Ensure brevity in your answer.  1.03. What is the ratio of the Total Labor Force (in %) of 1990 in Middle East & North Africa (all income levels) to that in Middle income?
Your answer should be compact. 0.71. What is the ratio of the Total Labor Force (in %) of 1991 in Middle East & North Africa (all income levels) to that in Middle income?
Give a very brief answer. 0.7. What is the ratio of the Total Labor Force (in %) in 1992 in Middle East & North Africa (all income levels) to that in Middle income?
Give a very brief answer. 0.7. What is the ratio of the Total Labor Force (in %) in 1993 in Middle East & North Africa (all income levels) to that in Middle income?
Ensure brevity in your answer.  0.7. What is the ratio of the Total Labor Force (in %) in 1990 in Middle East & North Africa (all income levels) to that in North America?
Provide a succinct answer. 0.66. What is the ratio of the Total Labor Force (in %) of 1991 in Middle East & North Africa (all income levels) to that in North America?
Your response must be concise. 0.66. What is the ratio of the Total Labor Force (in %) in 1992 in Middle East & North Africa (all income levels) to that in North America?
Offer a terse response. 0.65. What is the ratio of the Total Labor Force (in %) of 1993 in Middle East & North Africa (all income levels) to that in North America?
Provide a succinct answer. 0.66. What is the ratio of the Total Labor Force (in %) in 1990 in Middle East & North Africa (all income levels) to that in OECD members?
Provide a succinct answer. 0.72. What is the ratio of the Total Labor Force (in %) in 1991 in Middle East & North Africa (all income levels) to that in OECD members?
Ensure brevity in your answer.  0.71. What is the ratio of the Total Labor Force (in %) of 1992 in Middle East & North Africa (all income levels) to that in OECD members?
Ensure brevity in your answer.  0.71. What is the ratio of the Total Labor Force (in %) in 1993 in Middle East & North Africa (all income levels) to that in OECD members?
Provide a short and direct response. 0.72. What is the ratio of the Total Labor Force (in %) of 1990 in Middle East & North Africa (developing only) to that in Middle income?
Ensure brevity in your answer.  0.69. What is the ratio of the Total Labor Force (in %) of 1991 in Middle East & North Africa (developing only) to that in Middle income?
Your response must be concise. 0.68. What is the ratio of the Total Labor Force (in %) in 1992 in Middle East & North Africa (developing only) to that in Middle income?
Your answer should be very brief. 0.68. What is the ratio of the Total Labor Force (in %) of 1993 in Middle East & North Africa (developing only) to that in Middle income?
Ensure brevity in your answer.  0.68. What is the ratio of the Total Labor Force (in %) of 1990 in Middle East & North Africa (developing only) to that in North America?
Provide a succinct answer. 0.64. What is the ratio of the Total Labor Force (in %) of 1991 in Middle East & North Africa (developing only) to that in North America?
Your answer should be compact. 0.64. What is the ratio of the Total Labor Force (in %) of 1992 in Middle East & North Africa (developing only) to that in North America?
Your response must be concise. 0.64. What is the ratio of the Total Labor Force (in %) in 1993 in Middle East & North Africa (developing only) to that in North America?
Make the answer very short. 0.64. What is the ratio of the Total Labor Force (in %) in 1990 in Middle East & North Africa (developing only) to that in OECD members?
Your answer should be compact. 0.71. What is the ratio of the Total Labor Force (in %) in 1991 in Middle East & North Africa (developing only) to that in OECD members?
Your answer should be very brief. 0.7. What is the ratio of the Total Labor Force (in %) in 1992 in Middle East & North Africa (developing only) to that in OECD members?
Ensure brevity in your answer.  0.69. What is the ratio of the Total Labor Force (in %) in 1993 in Middle East & North Africa (developing only) to that in OECD members?
Your answer should be very brief. 0.7. What is the ratio of the Total Labor Force (in %) of 1990 in Middle income to that in North America?
Provide a short and direct response. 0.93. What is the ratio of the Total Labor Force (in %) in 1991 in Middle income to that in North America?
Your answer should be very brief. 0.94. What is the ratio of the Total Labor Force (in %) of 1992 in Middle income to that in North America?
Keep it short and to the point. 0.94. What is the ratio of the Total Labor Force (in %) in 1993 in Middle income to that in North America?
Provide a short and direct response. 0.94. What is the ratio of the Total Labor Force (in %) of 1990 in Middle income to that in OECD members?
Offer a very short reply. 1.03. What is the ratio of the Total Labor Force (in %) in 1991 in Middle income to that in OECD members?
Your response must be concise. 1.02. What is the ratio of the Total Labor Force (in %) of 1992 in Middle income to that in OECD members?
Ensure brevity in your answer.  1.02. What is the ratio of the Total Labor Force (in %) in 1993 in Middle income to that in OECD members?
Your response must be concise. 1.02. What is the ratio of the Total Labor Force (in %) of 1990 in North America to that in OECD members?
Your answer should be compact. 1.1. What is the ratio of the Total Labor Force (in %) of 1991 in North America to that in OECD members?
Provide a short and direct response. 1.09. What is the ratio of the Total Labor Force (in %) in 1992 in North America to that in OECD members?
Offer a very short reply. 1.09. What is the ratio of the Total Labor Force (in %) of 1993 in North America to that in OECD members?
Keep it short and to the point. 1.1. What is the difference between the highest and the second highest Total Labor Force (in %) of 1990?
Ensure brevity in your answer.  4.95. What is the difference between the highest and the second highest Total Labor Force (in %) in 1991?
Make the answer very short. 4.6. What is the difference between the highest and the second highest Total Labor Force (in %) in 1992?
Ensure brevity in your answer.  4.84. What is the difference between the highest and the second highest Total Labor Force (in %) in 1993?
Make the answer very short. 4.9. What is the difference between the highest and the lowest Total Labor Force (in %) of 1990?
Keep it short and to the point. 26.99. What is the difference between the highest and the lowest Total Labor Force (in %) of 1991?
Give a very brief answer. 27.15. What is the difference between the highest and the lowest Total Labor Force (in %) in 1992?
Keep it short and to the point. 27.53. What is the difference between the highest and the lowest Total Labor Force (in %) of 1993?
Ensure brevity in your answer.  27.2. 